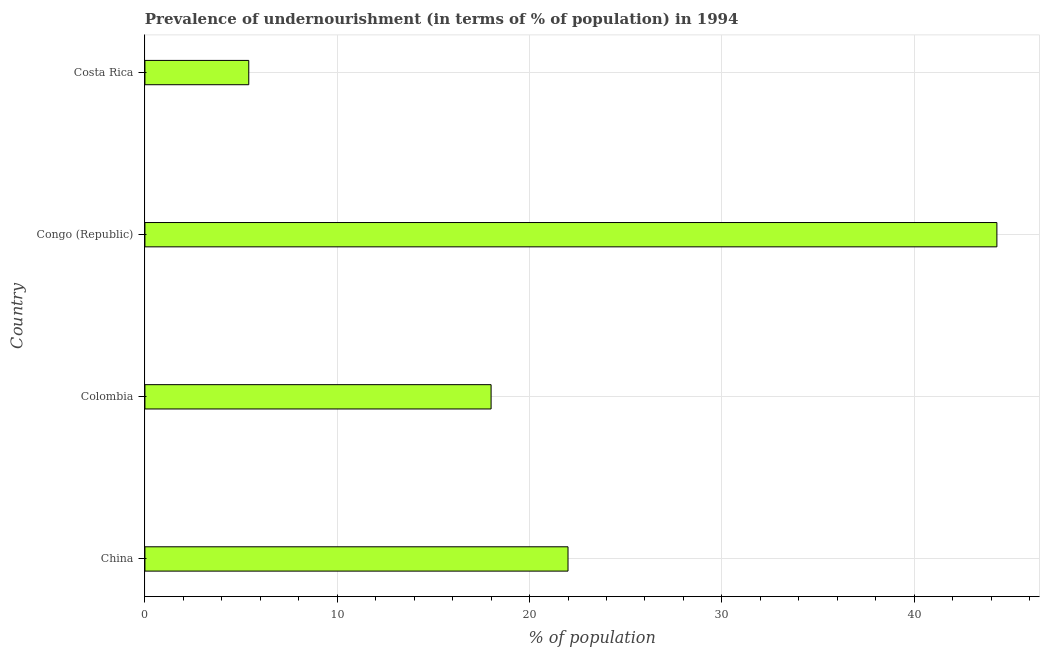Does the graph contain grids?
Your response must be concise. Yes. What is the title of the graph?
Make the answer very short. Prevalence of undernourishment (in terms of % of population) in 1994. What is the label or title of the X-axis?
Provide a short and direct response. % of population. What is the label or title of the Y-axis?
Your answer should be very brief. Country. What is the percentage of undernourished population in Costa Rica?
Offer a terse response. 5.4. Across all countries, what is the maximum percentage of undernourished population?
Ensure brevity in your answer.  44.3. In which country was the percentage of undernourished population maximum?
Provide a short and direct response. Congo (Republic). In which country was the percentage of undernourished population minimum?
Ensure brevity in your answer.  Costa Rica. What is the sum of the percentage of undernourished population?
Offer a very short reply. 89.7. What is the difference between the percentage of undernourished population in Colombia and Costa Rica?
Your answer should be compact. 12.6. What is the average percentage of undernourished population per country?
Offer a very short reply. 22.43. What is the ratio of the percentage of undernourished population in Colombia to that in Congo (Republic)?
Offer a very short reply. 0.41. Is the difference between the percentage of undernourished population in China and Congo (Republic) greater than the difference between any two countries?
Your answer should be compact. No. What is the difference between the highest and the second highest percentage of undernourished population?
Give a very brief answer. 22.3. What is the difference between the highest and the lowest percentage of undernourished population?
Your answer should be very brief. 38.9. In how many countries, is the percentage of undernourished population greater than the average percentage of undernourished population taken over all countries?
Provide a short and direct response. 1. Are all the bars in the graph horizontal?
Offer a terse response. Yes. What is the difference between two consecutive major ticks on the X-axis?
Keep it short and to the point. 10. Are the values on the major ticks of X-axis written in scientific E-notation?
Give a very brief answer. No. What is the % of population in Colombia?
Provide a short and direct response. 18. What is the % of population in Congo (Republic)?
Provide a short and direct response. 44.3. What is the difference between the % of population in China and Congo (Republic)?
Keep it short and to the point. -22.3. What is the difference between the % of population in Colombia and Congo (Republic)?
Your answer should be compact. -26.3. What is the difference between the % of population in Congo (Republic) and Costa Rica?
Offer a very short reply. 38.9. What is the ratio of the % of population in China to that in Colombia?
Ensure brevity in your answer.  1.22. What is the ratio of the % of population in China to that in Congo (Republic)?
Make the answer very short. 0.5. What is the ratio of the % of population in China to that in Costa Rica?
Keep it short and to the point. 4.07. What is the ratio of the % of population in Colombia to that in Congo (Republic)?
Keep it short and to the point. 0.41. What is the ratio of the % of population in Colombia to that in Costa Rica?
Provide a succinct answer. 3.33. What is the ratio of the % of population in Congo (Republic) to that in Costa Rica?
Ensure brevity in your answer.  8.2. 